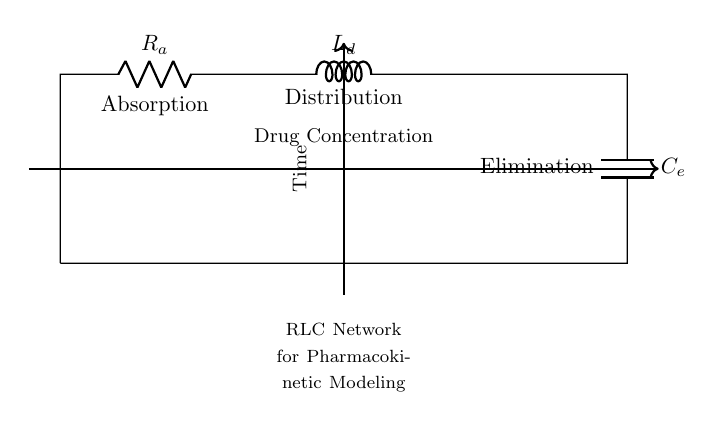What components are present in this circuit? The components visible in the circuit are a resistor, an inductor, and a capacitor. Specifically, they are labeled as Absorption (R), Distribution (L), and Elimination (C).
Answer: Resistor, inductor, capacitor What is the primary function represented by the resistor? The resistor in this circuit is labeled "Absorption," indicating that it simulates the process of drug absorption in pharmacokinetic studies.
Answer: Absorption What does the inductor represent in this RLC network? The inductor labeled "Distribution" signifies the distribution phase of the drug within the body as it moves through various tissues and organs after absorption.
Answer: Distribution How is drug concentration indicated in the circuit diagram? Drug concentration is indicated by the arrow labeled "Drug Concentration," which connects to the components, showing the flow of concentration through the network.
Answer: Drug Concentration What is the role of the capacitor in the RLC network? The capacitor, labeled "Elimination," is responsible for simulating the drug elimination process from the body, reflecting how drugs are removed over time.
Answer: Elimination How do the elements connect in this circuit? The components are connected in series, starting from the resistor to the inductor and finally to the capacitor, completing the circuit loop.
Answer: Series connection What aspect of pharmacokinetics does this circuit simulate? This RLC network simulates the absorption, distribution, and elimination phases of drugs in pharmacokinetic studies, reflecting their dynamic behavior in the body.
Answer: Pharmacokinetics 